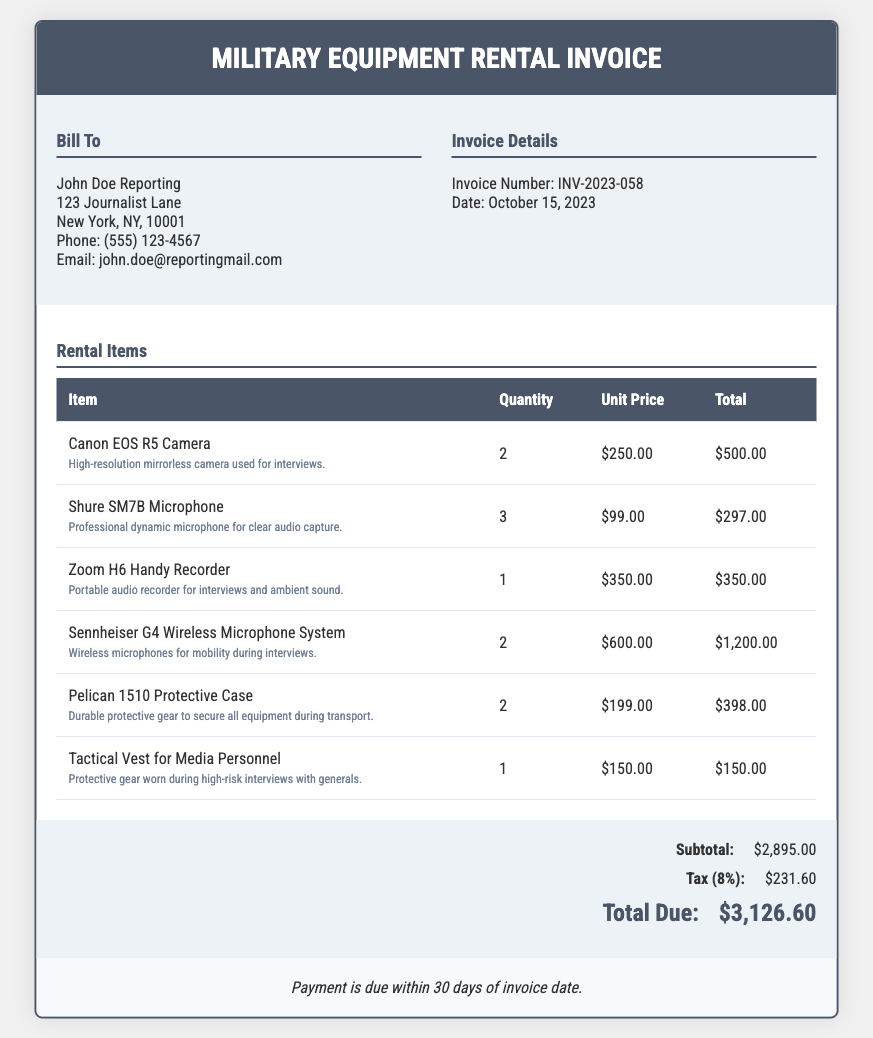What is the invoice number? The invoice number is clearly stated in the invoice details section for reference.
Answer: INV-2023-058 What is the date of the invoice? The date of the invoice is mentioned in the invoice details section.
Answer: October 15, 2023 How many Canon EOS R5 Cameras were rented? The quantity rented for each item is specified in the rental items table.
Answer: 2 What is the total cost for the Shure SM7B Microphones? The total for the Shure SM7B Microphones is calculated based on the quantity and unit price in the rental items table.
Answer: $297.00 What is the subtotal amount before tax? The subtotal is calculated by adding all costs before tax, which is listed in the summary section.
Answer: $2,895.00 How much is the tax applied to the invoice? The invoice provides a specific amount for the tax calculated at 8%.
Answer: $231.60 What is the total amount due? The total amount due is presented in the summary section as a final amount owed.
Answer: $3,126.60 What type of protective gear is mentioned in the invoice? The types of protective gear specified in the rental items include descriptions of the items.
Answer: Tactical Vest for Media Personnel What is the payment term indicated in the invoice? The payment terms detail when the payment is expected relative to the invoice date.
Answer: 30 days 